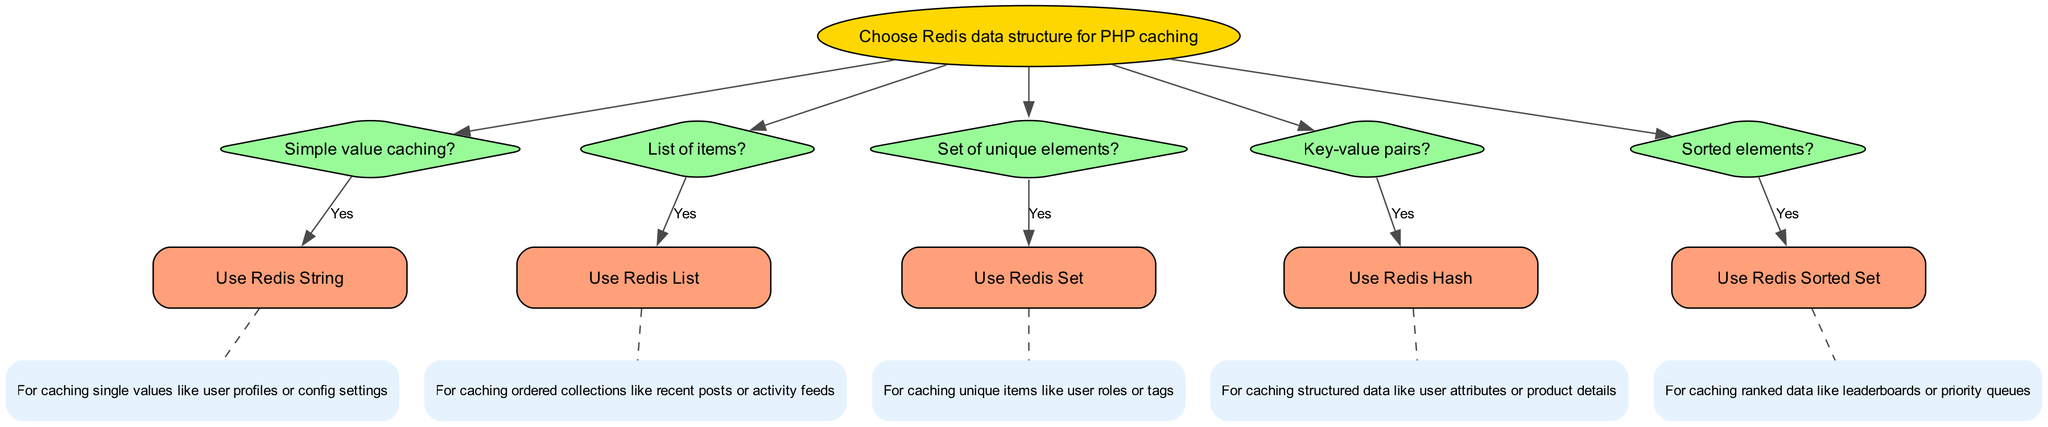What is the root node of the decision tree? The root node is labeled "Choose Redis data structure for PHP caching". This is the starting point of the decision tree, from which all other nodes branch out.
Answer: Choose Redis data structure for PHP caching How many types of data structures are suggested in the diagram? The diagram suggests five types of data structures: String, List, Set, Hash, and Sorted Set. Each of these corresponds to a different type of caching scenario outlined in the nodes.
Answer: Five What should you use for caching unique elements? The diagram specifies to use a "Redis Set" for caching unique elements. This is illustrated as a branch stemming from the relevant question node in the decision tree.
Answer: Redis Set If you need to cache ordered collections, which data structure is recommended? The recommendation for caching ordered collections is to use a "Redis List". This can be traced from the question node asking about "List of items?".
Answer: Redis List Which data structure is for caching single values? According to the diagram, the data structure for caching single values is a "Redis String". This is derived directly from the node that addresses simple value caching.
Answer: Redis String What type of data structure is used for caching ranked data? The diagram indicates that a "Redis Sorted Set" is used for caching ranked data, which is explicitly mentioned in the related question about scored elements.
Answer: Redis Sorted Set What is the relationship between "Key-value pairs?" and "Use Redis Hash"? The relationship is direct; if the scenario indicated is "Key-value pairs?", it leads to the recommendation to "Use Redis Hash". This is a clear path in the decision-making process of the tree.
Answer: Direct relationship In the case of caching user attributes, which data structure is advisable? For caching user attributes, the diagram advises using a "Redis Hash". This can be inferred from the caching scenario that corresponds to key-value pairs, where structured data is emphasized.
Answer: Redis Hash Which node confirms the use of Redis List, and what does it describe? The node confirming the use of Redis List is "List of items?". It describes that Redis List is for caching ordered collections like recent posts or activity feeds.
Answer: List of items?; Caching ordered collections like recent posts or activity feeds 